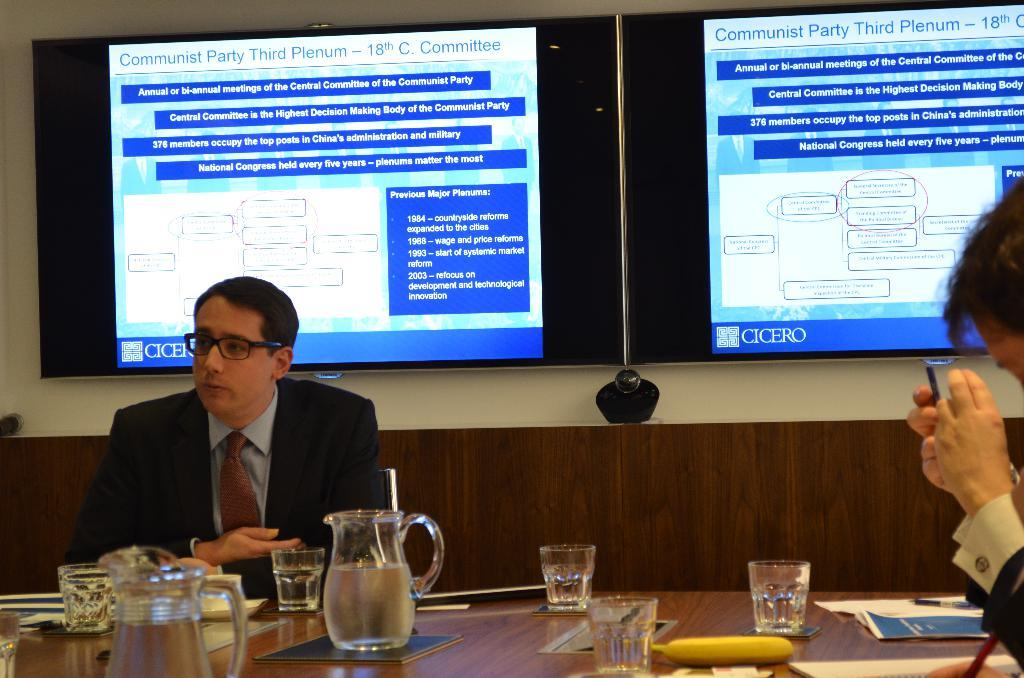<image>
Render a clear and concise summary of the photo. The monitor has Cicero in the lower left hand corner. 